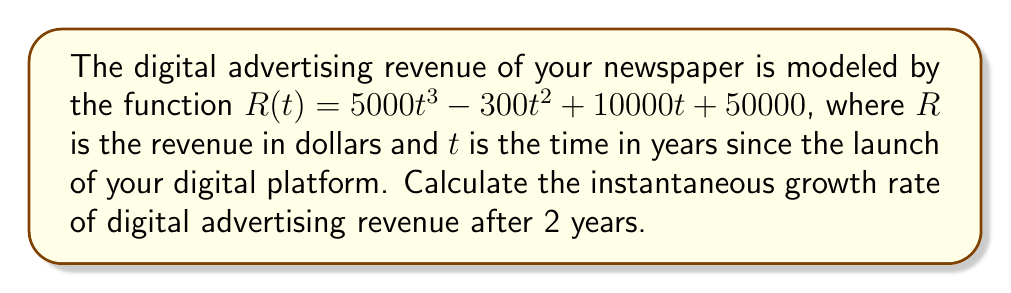Can you answer this question? To find the instantaneous growth rate of digital advertising revenue after 2 years, we need to calculate the derivative of the revenue function $R(t)$ and evaluate it at $t=2$. This will give us the rate of change of revenue with respect to time at that specific point.

Step 1: Calculate the derivative of $R(t)$.
$$\frac{dR}{dt} = R'(t) = (5000t^3 - 300t^2 + 10000t + 50000)'$$
$$R'(t) = 15000t^2 - 600t + 10000$$

Step 2: Evaluate $R'(t)$ at $t=2$.
$$R'(2) = 15000(2)^2 - 600(2) + 10000$$
$$R'(2) = 15000(4) - 1200 + 10000$$
$$R'(2) = 60000 - 1200 + 10000$$
$$R'(2) = 68800$$

The instantaneous growth rate of digital advertising revenue after 2 years is $68,800 dollars per year.
Answer: $68,800 dollars per year 